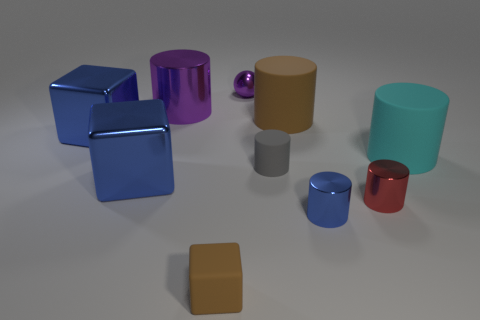Is the number of big metal cylinders greater than the number of big red rubber cubes?
Provide a succinct answer. Yes. What number of objects are either blue cylinders right of the gray object or cyan matte things?
Ensure brevity in your answer.  2. Is there a cyan matte thing of the same size as the gray object?
Your answer should be compact. No. Are there fewer large purple rubber cubes than purple cylinders?
Make the answer very short. Yes. What number of spheres are either gray rubber objects or matte things?
Your response must be concise. 0. How many tiny blocks have the same color as the tiny matte cylinder?
Your answer should be very brief. 0. There is a metal object that is to the right of the tiny brown rubber cube and behind the big brown rubber thing; what is its size?
Your answer should be very brief. Small. Are there fewer blue cubes that are behind the cyan cylinder than brown rubber objects?
Make the answer very short. Yes. Is the material of the small gray object the same as the tiny blue cylinder?
Your answer should be compact. No. How many things are metallic objects or small brown metallic cubes?
Offer a terse response. 6. 